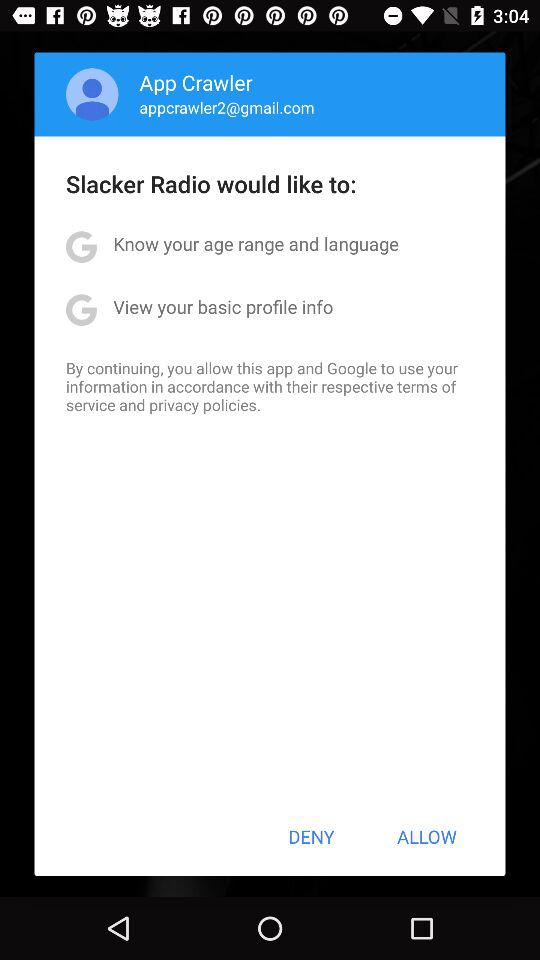What is the email address? The email address is appcrawler2@gmail.com. 